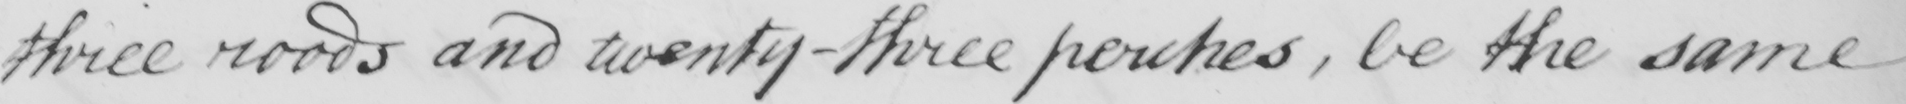Transcribe the text shown in this historical manuscript line. three roods and twenty-three perches , be the same 